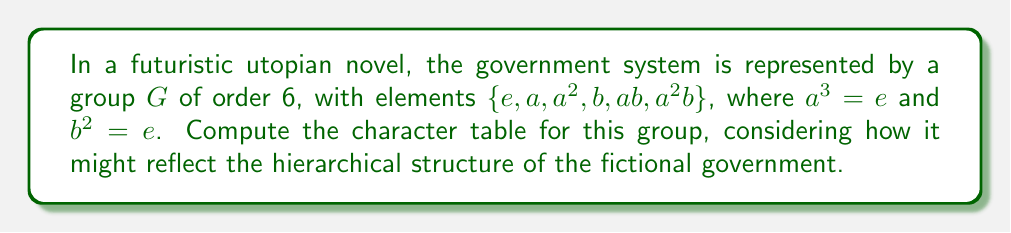What is the answer to this math problem? To compute the character table for this group, we'll follow these steps:

1) First, identify the conjugacy classes:
   $[e] = \{e\}$
   $[a] = \{a, a^2\}$
   $[b] = \{b, ab, a^2b\}$

2) The number of irreducible representations equals the number of conjugacy classes, so there are 3 irreducible representations.

3) The dimensions of these representations must satisfy:
   $1^2 + 1^2 + 2^2 = 6$
   So we have two 1-dimensional representations and one 2-dimensional representation.

4) For the trivial representation $\chi_1$, all characters are 1.

5) For the second 1-dimensional representation $\chi_2$:
   $\chi_2(e) = 1$
   $\chi_2(a) = 1$ (as $a^3 = e$)
   $\chi_2(b) = -1$ (as $b^2 = e$, but $\chi_2(b) \neq 1$)

6) For the 2-dimensional representation $\chi_3$:
   $\chi_3(e) = 2$
   $\chi_3(a) = -1$ (as trace of a 120° rotation matrix)
   $\chi_3(b) = 0$ (as trace of a reflection matrix)

7) Verify orthogonality relations to confirm correctness.

The resulting character table is:

$$
\begin{array}{c|ccc}
G & [e] & [a] & [b] \\
\hline
\chi_1 & 1 & 1 & 1 \\
\chi_2 & 1 & 1 & -1 \\
\chi_3 & 2 & -1 & 0
\end{array}
$$

This table could represent different levels in the government hierarchy: $\chi_1$ for universal laws, $\chi_2$ for executive decisions, and $\chi_3$ for complex legislative processes.
Answer: $$
\begin{array}{c|ccc}
G & [e] & [a] & [b] \\
\hline
\chi_1 & 1 & 1 & 1 \\
\chi_2 & 1 & 1 & -1 \\
\chi_3 & 2 & -1 & 0
\end{array}
$$ 